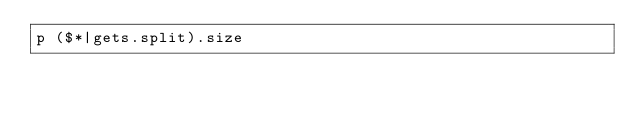<code> <loc_0><loc_0><loc_500><loc_500><_Ruby_>p ($*|gets.split).size</code> 